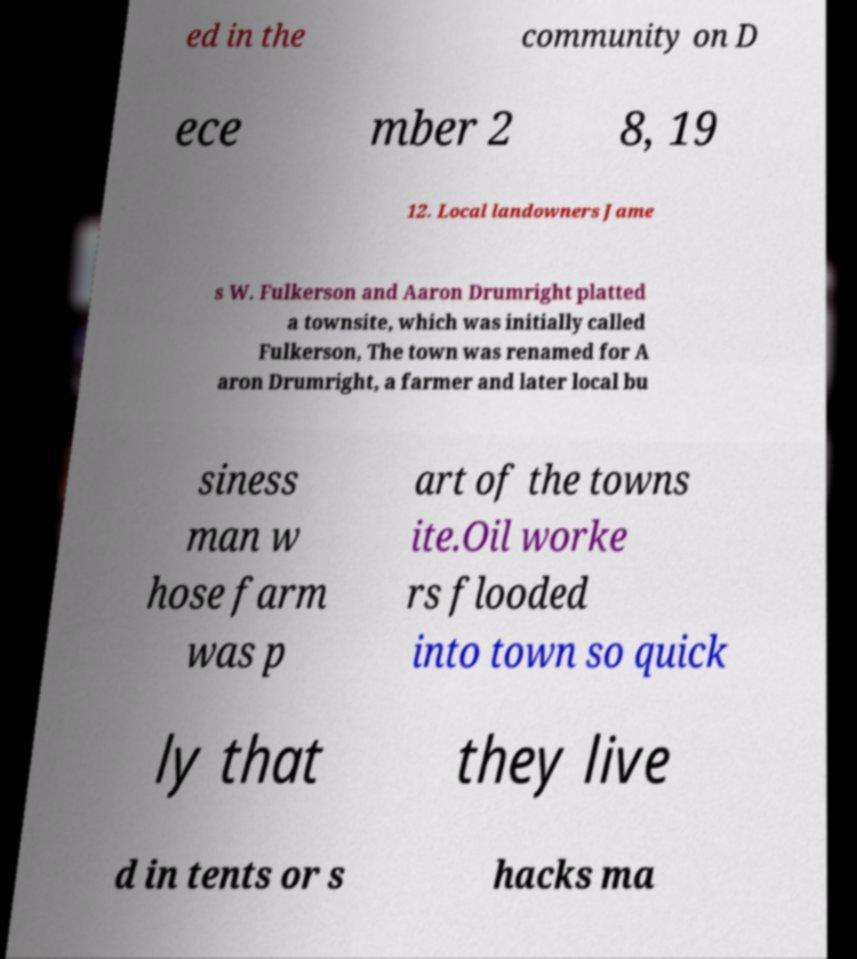For documentation purposes, I need the text within this image transcribed. Could you provide that? ed in the community on D ece mber 2 8, 19 12. Local landowners Jame s W. Fulkerson and Aaron Drumright platted a townsite, which was initially called Fulkerson, The town was renamed for A aron Drumright, a farmer and later local bu siness man w hose farm was p art of the towns ite.Oil worke rs flooded into town so quick ly that they live d in tents or s hacks ma 